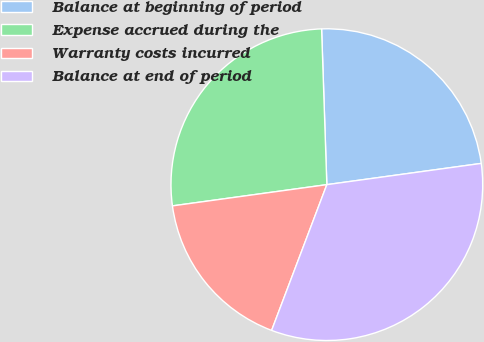Convert chart to OTSL. <chart><loc_0><loc_0><loc_500><loc_500><pie_chart><fcel>Balance at beginning of period<fcel>Expense accrued during the<fcel>Warranty costs incurred<fcel>Balance at end of period<nl><fcel>23.36%<fcel>26.64%<fcel>17.06%<fcel>32.94%<nl></chart> 